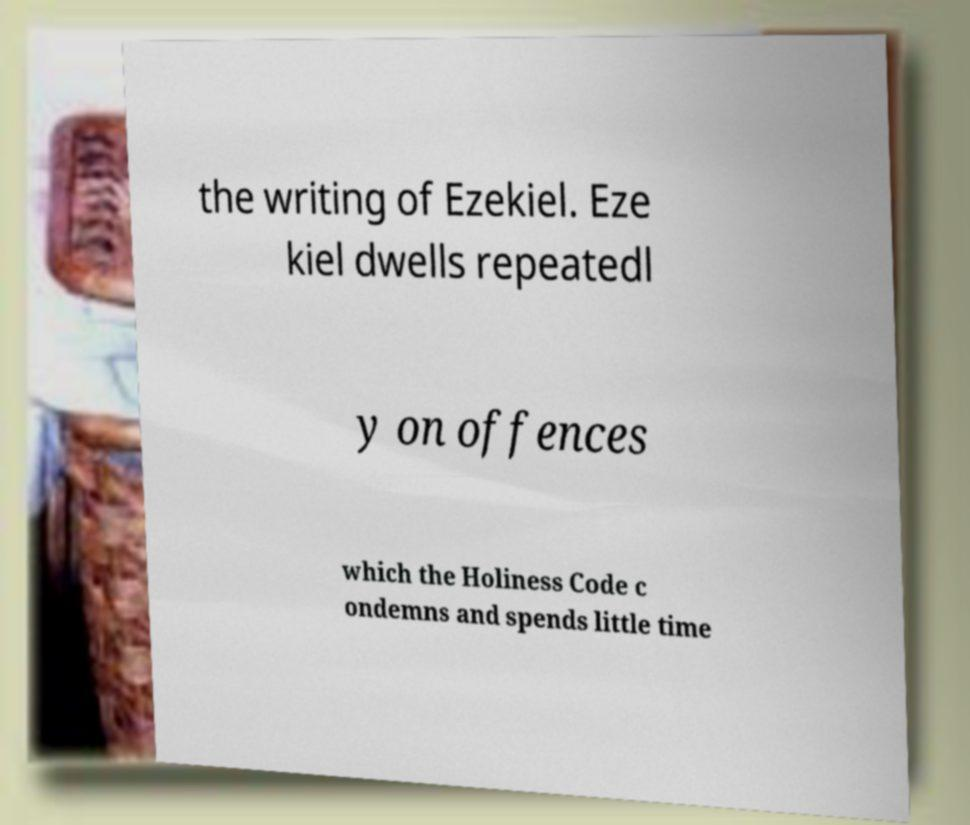For documentation purposes, I need the text within this image transcribed. Could you provide that? the writing of Ezekiel. Eze kiel dwells repeatedl y on offences which the Holiness Code c ondemns and spends little time 